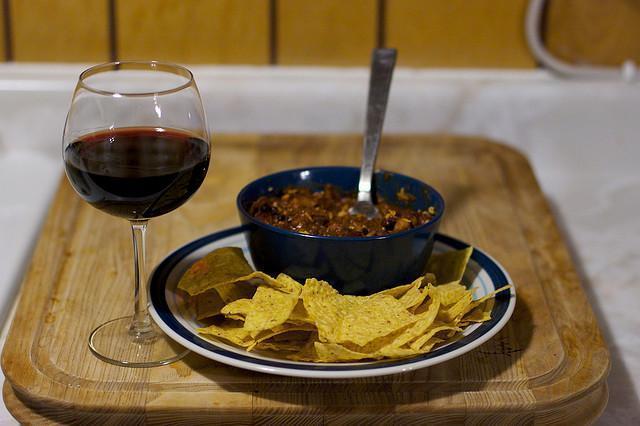How many wine glasses are there?
Give a very brief answer. 1. How many glasses are there?
Give a very brief answer. 1. How many bowls are there?
Give a very brief answer. 1. 